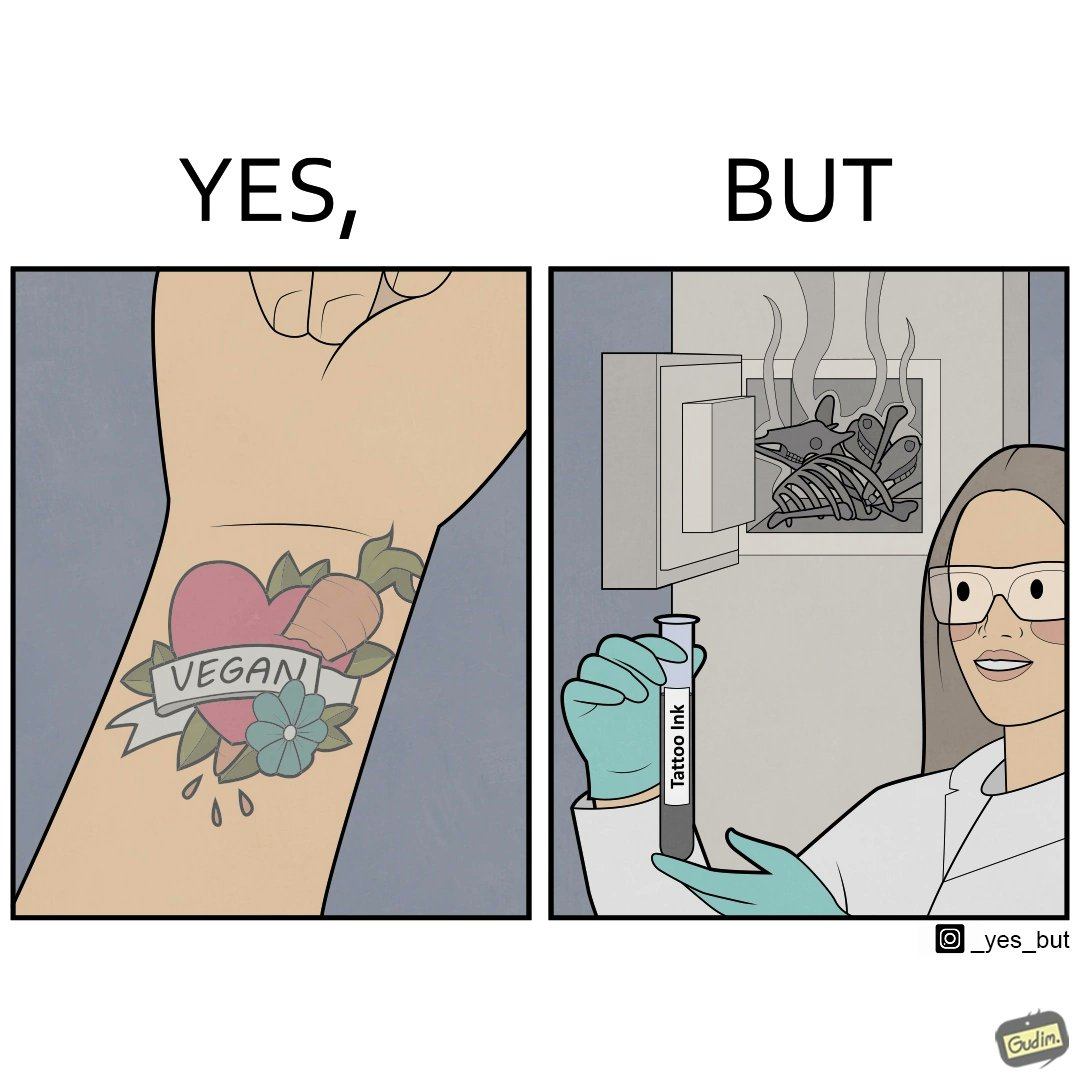What is shown in this image? The irony in this video is that people try to promote and embrace veganism end up using products that are not animal-free. 